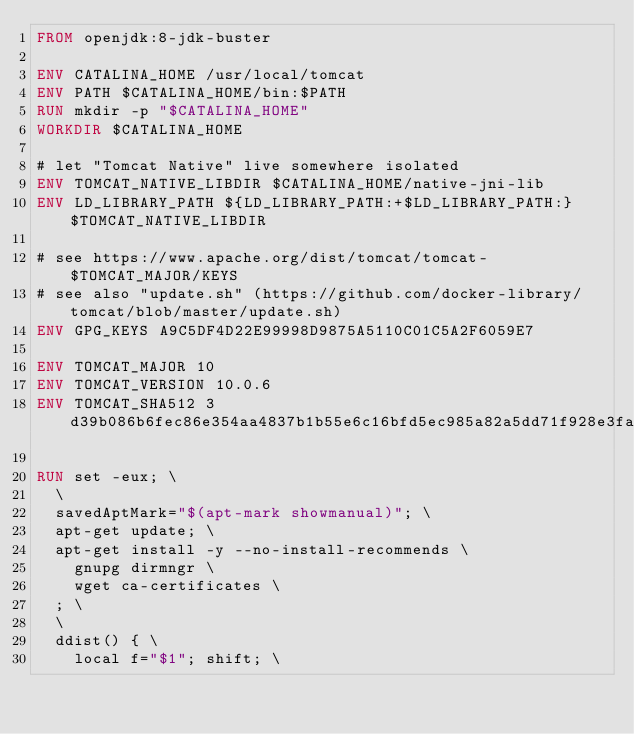Convert code to text. <code><loc_0><loc_0><loc_500><loc_500><_Dockerfile_>FROM openjdk:8-jdk-buster

ENV CATALINA_HOME /usr/local/tomcat
ENV PATH $CATALINA_HOME/bin:$PATH
RUN mkdir -p "$CATALINA_HOME"
WORKDIR $CATALINA_HOME

# let "Tomcat Native" live somewhere isolated
ENV TOMCAT_NATIVE_LIBDIR $CATALINA_HOME/native-jni-lib
ENV LD_LIBRARY_PATH ${LD_LIBRARY_PATH:+$LD_LIBRARY_PATH:}$TOMCAT_NATIVE_LIBDIR

# see https://www.apache.org/dist/tomcat/tomcat-$TOMCAT_MAJOR/KEYS
# see also "update.sh" (https://github.com/docker-library/tomcat/blob/master/update.sh)
ENV GPG_KEYS A9C5DF4D22E99998D9875A5110C01C5A2F6059E7

ENV TOMCAT_MAJOR 10
ENV TOMCAT_VERSION 10.0.6
ENV TOMCAT_SHA512 3d39b086b6fec86e354aa4837b1b55e6c16bfd5ec985a82a5dd71f928e3fab5370b2964a5a1098cfe05ca63d031f198773b18b1f8c7c6cdee6c90aa0644fb2f2

RUN set -eux; \
	\
	savedAptMark="$(apt-mark showmanual)"; \
	apt-get update; \
	apt-get install -y --no-install-recommends \
		gnupg dirmngr \
		wget ca-certificates \
	; \
	\
	ddist() { \
		local f="$1"; shift; \</code> 